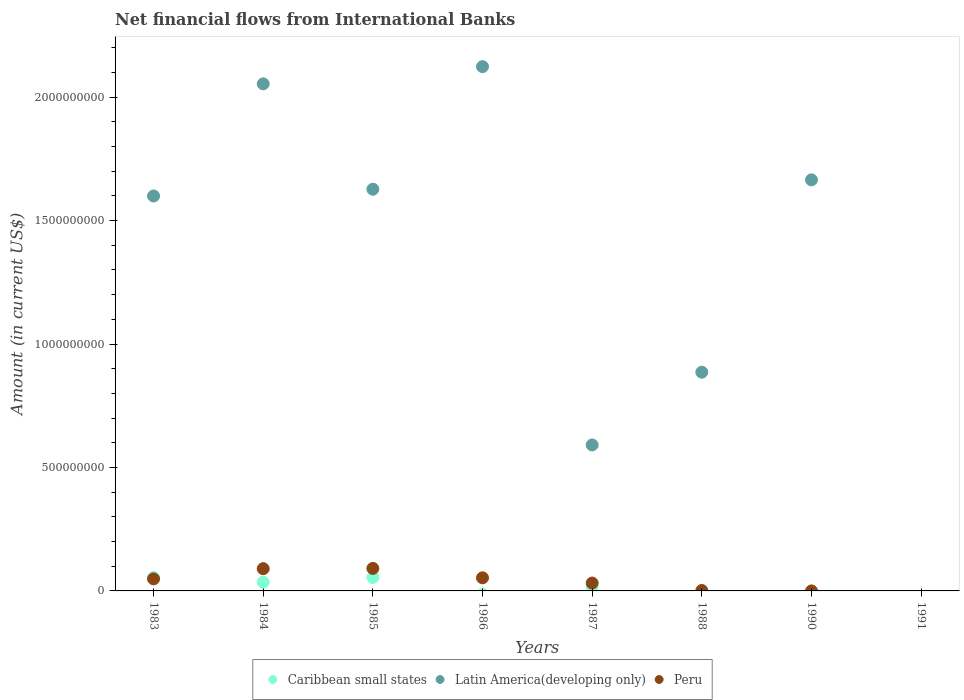Is the number of dotlines equal to the number of legend labels?
Provide a succinct answer. No. What is the net financial aid flows in Peru in 1986?
Make the answer very short. 5.31e+07. Across all years, what is the maximum net financial aid flows in Latin America(developing only)?
Ensure brevity in your answer.  2.12e+09. In which year was the net financial aid flows in Latin America(developing only) maximum?
Keep it short and to the point. 1986. What is the total net financial aid flows in Peru in the graph?
Offer a very short reply. 3.17e+08. What is the difference between the net financial aid flows in Latin America(developing only) in 1985 and that in 1988?
Give a very brief answer. 7.41e+08. What is the difference between the net financial aid flows in Caribbean small states in 1985 and the net financial aid flows in Latin America(developing only) in 1990?
Make the answer very short. -1.61e+09. What is the average net financial aid flows in Caribbean small states per year?
Provide a succinct answer. 2.01e+07. In the year 1987, what is the difference between the net financial aid flows in Peru and net financial aid flows in Latin America(developing only)?
Keep it short and to the point. -5.59e+08. What is the ratio of the net financial aid flows in Peru in 1983 to that in 1985?
Provide a short and direct response. 0.54. Is the net financial aid flows in Caribbean small states in 1983 less than that in 1985?
Give a very brief answer. No. What is the difference between the highest and the second highest net financial aid flows in Caribbean small states?
Provide a short and direct response. 3.59e+04. What is the difference between the highest and the lowest net financial aid flows in Caribbean small states?
Offer a terse response. 5.47e+07. Is the net financial aid flows in Latin America(developing only) strictly less than the net financial aid flows in Peru over the years?
Your answer should be very brief. No. How many dotlines are there?
Provide a succinct answer. 3. Does the graph contain any zero values?
Keep it short and to the point. Yes. Does the graph contain grids?
Offer a very short reply. No. How many legend labels are there?
Your response must be concise. 3. What is the title of the graph?
Make the answer very short. Net financial flows from International Banks. Does "United States" appear as one of the legend labels in the graph?
Your answer should be very brief. No. What is the Amount (in current US$) in Caribbean small states in 1983?
Your answer should be compact. 5.47e+07. What is the Amount (in current US$) of Latin America(developing only) in 1983?
Make the answer very short. 1.60e+09. What is the Amount (in current US$) in Peru in 1983?
Give a very brief answer. 4.88e+07. What is the Amount (in current US$) of Caribbean small states in 1984?
Keep it short and to the point. 3.54e+07. What is the Amount (in current US$) of Latin America(developing only) in 1984?
Your answer should be very brief. 2.05e+09. What is the Amount (in current US$) of Peru in 1984?
Offer a terse response. 9.01e+07. What is the Amount (in current US$) of Caribbean small states in 1985?
Make the answer very short. 5.47e+07. What is the Amount (in current US$) in Latin America(developing only) in 1985?
Offer a terse response. 1.63e+09. What is the Amount (in current US$) in Peru in 1985?
Ensure brevity in your answer.  9.12e+07. What is the Amount (in current US$) in Caribbean small states in 1986?
Ensure brevity in your answer.  0. What is the Amount (in current US$) of Latin America(developing only) in 1986?
Offer a terse response. 2.12e+09. What is the Amount (in current US$) of Peru in 1986?
Make the answer very short. 5.31e+07. What is the Amount (in current US$) in Caribbean small states in 1987?
Offer a very short reply. 1.57e+07. What is the Amount (in current US$) in Latin America(developing only) in 1987?
Your answer should be very brief. 5.91e+08. What is the Amount (in current US$) in Peru in 1987?
Ensure brevity in your answer.  3.19e+07. What is the Amount (in current US$) in Latin America(developing only) in 1988?
Your answer should be very brief. 8.86e+08. What is the Amount (in current US$) of Peru in 1988?
Make the answer very short. 1.75e+06. What is the Amount (in current US$) in Latin America(developing only) in 1990?
Provide a succinct answer. 1.67e+09. What is the Amount (in current US$) of Peru in 1990?
Offer a very short reply. 0. Across all years, what is the maximum Amount (in current US$) in Caribbean small states?
Your answer should be compact. 5.47e+07. Across all years, what is the maximum Amount (in current US$) in Latin America(developing only)?
Your answer should be very brief. 2.12e+09. Across all years, what is the maximum Amount (in current US$) of Peru?
Your response must be concise. 9.12e+07. Across all years, what is the minimum Amount (in current US$) in Caribbean small states?
Your answer should be very brief. 0. Across all years, what is the minimum Amount (in current US$) in Latin America(developing only)?
Provide a short and direct response. 0. What is the total Amount (in current US$) of Caribbean small states in the graph?
Give a very brief answer. 1.60e+08. What is the total Amount (in current US$) of Latin America(developing only) in the graph?
Offer a very short reply. 1.05e+1. What is the total Amount (in current US$) in Peru in the graph?
Your answer should be compact. 3.17e+08. What is the difference between the Amount (in current US$) of Caribbean small states in 1983 and that in 1984?
Keep it short and to the point. 1.93e+07. What is the difference between the Amount (in current US$) of Latin America(developing only) in 1983 and that in 1984?
Your answer should be compact. -4.54e+08. What is the difference between the Amount (in current US$) of Peru in 1983 and that in 1984?
Make the answer very short. -4.13e+07. What is the difference between the Amount (in current US$) in Caribbean small states in 1983 and that in 1985?
Ensure brevity in your answer.  3.59e+04. What is the difference between the Amount (in current US$) in Latin America(developing only) in 1983 and that in 1985?
Make the answer very short. -2.74e+07. What is the difference between the Amount (in current US$) in Peru in 1983 and that in 1985?
Provide a succinct answer. -4.24e+07. What is the difference between the Amount (in current US$) in Latin America(developing only) in 1983 and that in 1986?
Make the answer very short. -5.24e+08. What is the difference between the Amount (in current US$) in Peru in 1983 and that in 1986?
Keep it short and to the point. -4.27e+06. What is the difference between the Amount (in current US$) in Caribbean small states in 1983 and that in 1987?
Offer a very short reply. 3.90e+07. What is the difference between the Amount (in current US$) in Latin America(developing only) in 1983 and that in 1987?
Your answer should be compact. 1.01e+09. What is the difference between the Amount (in current US$) in Peru in 1983 and that in 1987?
Provide a succinct answer. 1.69e+07. What is the difference between the Amount (in current US$) of Latin America(developing only) in 1983 and that in 1988?
Keep it short and to the point. 7.14e+08. What is the difference between the Amount (in current US$) in Peru in 1983 and that in 1988?
Your answer should be compact. 4.70e+07. What is the difference between the Amount (in current US$) in Latin America(developing only) in 1983 and that in 1990?
Your answer should be compact. -6.53e+07. What is the difference between the Amount (in current US$) of Caribbean small states in 1984 and that in 1985?
Give a very brief answer. -1.93e+07. What is the difference between the Amount (in current US$) in Latin America(developing only) in 1984 and that in 1985?
Offer a very short reply. 4.27e+08. What is the difference between the Amount (in current US$) in Peru in 1984 and that in 1985?
Give a very brief answer. -1.07e+06. What is the difference between the Amount (in current US$) in Latin America(developing only) in 1984 and that in 1986?
Your response must be concise. -6.97e+07. What is the difference between the Amount (in current US$) of Peru in 1984 and that in 1986?
Provide a short and direct response. 3.70e+07. What is the difference between the Amount (in current US$) of Caribbean small states in 1984 and that in 1987?
Keep it short and to the point. 1.97e+07. What is the difference between the Amount (in current US$) in Latin America(developing only) in 1984 and that in 1987?
Make the answer very short. 1.46e+09. What is the difference between the Amount (in current US$) in Peru in 1984 and that in 1987?
Offer a very short reply. 5.82e+07. What is the difference between the Amount (in current US$) of Latin America(developing only) in 1984 and that in 1988?
Provide a short and direct response. 1.17e+09. What is the difference between the Amount (in current US$) of Peru in 1984 and that in 1988?
Provide a short and direct response. 8.84e+07. What is the difference between the Amount (in current US$) of Latin America(developing only) in 1984 and that in 1990?
Keep it short and to the point. 3.89e+08. What is the difference between the Amount (in current US$) of Latin America(developing only) in 1985 and that in 1986?
Make the answer very short. -4.96e+08. What is the difference between the Amount (in current US$) of Peru in 1985 and that in 1986?
Give a very brief answer. 3.81e+07. What is the difference between the Amount (in current US$) of Caribbean small states in 1985 and that in 1987?
Offer a very short reply. 3.89e+07. What is the difference between the Amount (in current US$) of Latin America(developing only) in 1985 and that in 1987?
Provide a succinct answer. 1.04e+09. What is the difference between the Amount (in current US$) of Peru in 1985 and that in 1987?
Your response must be concise. 5.93e+07. What is the difference between the Amount (in current US$) in Latin America(developing only) in 1985 and that in 1988?
Offer a terse response. 7.41e+08. What is the difference between the Amount (in current US$) in Peru in 1985 and that in 1988?
Offer a very short reply. 8.94e+07. What is the difference between the Amount (in current US$) of Latin America(developing only) in 1985 and that in 1990?
Make the answer very short. -3.80e+07. What is the difference between the Amount (in current US$) of Latin America(developing only) in 1986 and that in 1987?
Your answer should be very brief. 1.53e+09. What is the difference between the Amount (in current US$) of Peru in 1986 and that in 1987?
Offer a terse response. 2.12e+07. What is the difference between the Amount (in current US$) in Latin America(developing only) in 1986 and that in 1988?
Your answer should be very brief. 1.24e+09. What is the difference between the Amount (in current US$) of Peru in 1986 and that in 1988?
Offer a very short reply. 5.13e+07. What is the difference between the Amount (in current US$) in Latin America(developing only) in 1986 and that in 1990?
Offer a very short reply. 4.59e+08. What is the difference between the Amount (in current US$) of Latin America(developing only) in 1987 and that in 1988?
Provide a short and direct response. -2.95e+08. What is the difference between the Amount (in current US$) in Peru in 1987 and that in 1988?
Give a very brief answer. 3.01e+07. What is the difference between the Amount (in current US$) in Latin America(developing only) in 1987 and that in 1990?
Your response must be concise. -1.07e+09. What is the difference between the Amount (in current US$) in Latin America(developing only) in 1988 and that in 1990?
Your answer should be compact. -7.79e+08. What is the difference between the Amount (in current US$) in Caribbean small states in 1983 and the Amount (in current US$) in Latin America(developing only) in 1984?
Make the answer very short. -2.00e+09. What is the difference between the Amount (in current US$) in Caribbean small states in 1983 and the Amount (in current US$) in Peru in 1984?
Provide a succinct answer. -3.54e+07. What is the difference between the Amount (in current US$) in Latin America(developing only) in 1983 and the Amount (in current US$) in Peru in 1984?
Your answer should be very brief. 1.51e+09. What is the difference between the Amount (in current US$) in Caribbean small states in 1983 and the Amount (in current US$) in Latin America(developing only) in 1985?
Provide a succinct answer. -1.57e+09. What is the difference between the Amount (in current US$) of Caribbean small states in 1983 and the Amount (in current US$) of Peru in 1985?
Keep it short and to the point. -3.65e+07. What is the difference between the Amount (in current US$) of Latin America(developing only) in 1983 and the Amount (in current US$) of Peru in 1985?
Give a very brief answer. 1.51e+09. What is the difference between the Amount (in current US$) of Caribbean small states in 1983 and the Amount (in current US$) of Latin America(developing only) in 1986?
Keep it short and to the point. -2.07e+09. What is the difference between the Amount (in current US$) in Caribbean small states in 1983 and the Amount (in current US$) in Peru in 1986?
Give a very brief answer. 1.63e+06. What is the difference between the Amount (in current US$) of Latin America(developing only) in 1983 and the Amount (in current US$) of Peru in 1986?
Keep it short and to the point. 1.55e+09. What is the difference between the Amount (in current US$) of Caribbean small states in 1983 and the Amount (in current US$) of Latin America(developing only) in 1987?
Provide a short and direct response. -5.37e+08. What is the difference between the Amount (in current US$) in Caribbean small states in 1983 and the Amount (in current US$) in Peru in 1987?
Your response must be concise. 2.28e+07. What is the difference between the Amount (in current US$) of Latin America(developing only) in 1983 and the Amount (in current US$) of Peru in 1987?
Keep it short and to the point. 1.57e+09. What is the difference between the Amount (in current US$) in Caribbean small states in 1983 and the Amount (in current US$) in Latin America(developing only) in 1988?
Keep it short and to the point. -8.31e+08. What is the difference between the Amount (in current US$) of Caribbean small states in 1983 and the Amount (in current US$) of Peru in 1988?
Offer a terse response. 5.29e+07. What is the difference between the Amount (in current US$) of Latin America(developing only) in 1983 and the Amount (in current US$) of Peru in 1988?
Your answer should be compact. 1.60e+09. What is the difference between the Amount (in current US$) in Caribbean small states in 1983 and the Amount (in current US$) in Latin America(developing only) in 1990?
Your answer should be compact. -1.61e+09. What is the difference between the Amount (in current US$) of Caribbean small states in 1984 and the Amount (in current US$) of Latin America(developing only) in 1985?
Provide a short and direct response. -1.59e+09. What is the difference between the Amount (in current US$) of Caribbean small states in 1984 and the Amount (in current US$) of Peru in 1985?
Give a very brief answer. -5.58e+07. What is the difference between the Amount (in current US$) of Latin America(developing only) in 1984 and the Amount (in current US$) of Peru in 1985?
Give a very brief answer. 1.96e+09. What is the difference between the Amount (in current US$) of Caribbean small states in 1984 and the Amount (in current US$) of Latin America(developing only) in 1986?
Your answer should be compact. -2.09e+09. What is the difference between the Amount (in current US$) of Caribbean small states in 1984 and the Amount (in current US$) of Peru in 1986?
Provide a succinct answer. -1.77e+07. What is the difference between the Amount (in current US$) in Latin America(developing only) in 1984 and the Amount (in current US$) in Peru in 1986?
Your answer should be very brief. 2.00e+09. What is the difference between the Amount (in current US$) of Caribbean small states in 1984 and the Amount (in current US$) of Latin America(developing only) in 1987?
Give a very brief answer. -5.56e+08. What is the difference between the Amount (in current US$) of Caribbean small states in 1984 and the Amount (in current US$) of Peru in 1987?
Provide a succinct answer. 3.53e+06. What is the difference between the Amount (in current US$) in Latin America(developing only) in 1984 and the Amount (in current US$) in Peru in 1987?
Ensure brevity in your answer.  2.02e+09. What is the difference between the Amount (in current US$) in Caribbean small states in 1984 and the Amount (in current US$) in Latin America(developing only) in 1988?
Provide a short and direct response. -8.51e+08. What is the difference between the Amount (in current US$) of Caribbean small states in 1984 and the Amount (in current US$) of Peru in 1988?
Your answer should be compact. 3.36e+07. What is the difference between the Amount (in current US$) of Latin America(developing only) in 1984 and the Amount (in current US$) of Peru in 1988?
Give a very brief answer. 2.05e+09. What is the difference between the Amount (in current US$) in Caribbean small states in 1984 and the Amount (in current US$) in Latin America(developing only) in 1990?
Offer a very short reply. -1.63e+09. What is the difference between the Amount (in current US$) of Caribbean small states in 1985 and the Amount (in current US$) of Latin America(developing only) in 1986?
Provide a succinct answer. -2.07e+09. What is the difference between the Amount (in current US$) of Caribbean small states in 1985 and the Amount (in current US$) of Peru in 1986?
Your answer should be compact. 1.60e+06. What is the difference between the Amount (in current US$) of Latin America(developing only) in 1985 and the Amount (in current US$) of Peru in 1986?
Your answer should be compact. 1.57e+09. What is the difference between the Amount (in current US$) of Caribbean small states in 1985 and the Amount (in current US$) of Latin America(developing only) in 1987?
Your answer should be very brief. -5.37e+08. What is the difference between the Amount (in current US$) of Caribbean small states in 1985 and the Amount (in current US$) of Peru in 1987?
Offer a very short reply. 2.28e+07. What is the difference between the Amount (in current US$) of Latin America(developing only) in 1985 and the Amount (in current US$) of Peru in 1987?
Provide a succinct answer. 1.60e+09. What is the difference between the Amount (in current US$) in Caribbean small states in 1985 and the Amount (in current US$) in Latin America(developing only) in 1988?
Ensure brevity in your answer.  -8.31e+08. What is the difference between the Amount (in current US$) of Caribbean small states in 1985 and the Amount (in current US$) of Peru in 1988?
Keep it short and to the point. 5.29e+07. What is the difference between the Amount (in current US$) of Latin America(developing only) in 1985 and the Amount (in current US$) of Peru in 1988?
Your answer should be compact. 1.63e+09. What is the difference between the Amount (in current US$) of Caribbean small states in 1985 and the Amount (in current US$) of Latin America(developing only) in 1990?
Ensure brevity in your answer.  -1.61e+09. What is the difference between the Amount (in current US$) in Latin America(developing only) in 1986 and the Amount (in current US$) in Peru in 1987?
Provide a succinct answer. 2.09e+09. What is the difference between the Amount (in current US$) in Latin America(developing only) in 1986 and the Amount (in current US$) in Peru in 1988?
Ensure brevity in your answer.  2.12e+09. What is the difference between the Amount (in current US$) in Caribbean small states in 1987 and the Amount (in current US$) in Latin America(developing only) in 1988?
Your response must be concise. -8.70e+08. What is the difference between the Amount (in current US$) of Caribbean small states in 1987 and the Amount (in current US$) of Peru in 1988?
Provide a succinct answer. 1.40e+07. What is the difference between the Amount (in current US$) of Latin America(developing only) in 1987 and the Amount (in current US$) of Peru in 1988?
Your answer should be compact. 5.90e+08. What is the difference between the Amount (in current US$) in Caribbean small states in 1987 and the Amount (in current US$) in Latin America(developing only) in 1990?
Your response must be concise. -1.65e+09. What is the average Amount (in current US$) in Caribbean small states per year?
Give a very brief answer. 2.01e+07. What is the average Amount (in current US$) of Latin America(developing only) per year?
Provide a succinct answer. 1.32e+09. What is the average Amount (in current US$) of Peru per year?
Your answer should be very brief. 3.96e+07. In the year 1983, what is the difference between the Amount (in current US$) of Caribbean small states and Amount (in current US$) of Latin America(developing only)?
Your answer should be compact. -1.55e+09. In the year 1983, what is the difference between the Amount (in current US$) of Caribbean small states and Amount (in current US$) of Peru?
Offer a terse response. 5.90e+06. In the year 1983, what is the difference between the Amount (in current US$) in Latin America(developing only) and Amount (in current US$) in Peru?
Give a very brief answer. 1.55e+09. In the year 1984, what is the difference between the Amount (in current US$) of Caribbean small states and Amount (in current US$) of Latin America(developing only)?
Give a very brief answer. -2.02e+09. In the year 1984, what is the difference between the Amount (in current US$) in Caribbean small states and Amount (in current US$) in Peru?
Ensure brevity in your answer.  -5.47e+07. In the year 1984, what is the difference between the Amount (in current US$) of Latin America(developing only) and Amount (in current US$) of Peru?
Offer a very short reply. 1.96e+09. In the year 1985, what is the difference between the Amount (in current US$) of Caribbean small states and Amount (in current US$) of Latin America(developing only)?
Ensure brevity in your answer.  -1.57e+09. In the year 1985, what is the difference between the Amount (in current US$) of Caribbean small states and Amount (in current US$) of Peru?
Provide a succinct answer. -3.65e+07. In the year 1985, what is the difference between the Amount (in current US$) in Latin America(developing only) and Amount (in current US$) in Peru?
Ensure brevity in your answer.  1.54e+09. In the year 1986, what is the difference between the Amount (in current US$) of Latin America(developing only) and Amount (in current US$) of Peru?
Provide a short and direct response. 2.07e+09. In the year 1987, what is the difference between the Amount (in current US$) in Caribbean small states and Amount (in current US$) in Latin America(developing only)?
Offer a terse response. -5.76e+08. In the year 1987, what is the difference between the Amount (in current US$) of Caribbean small states and Amount (in current US$) of Peru?
Ensure brevity in your answer.  -1.61e+07. In the year 1987, what is the difference between the Amount (in current US$) in Latin America(developing only) and Amount (in current US$) in Peru?
Make the answer very short. 5.59e+08. In the year 1988, what is the difference between the Amount (in current US$) in Latin America(developing only) and Amount (in current US$) in Peru?
Make the answer very short. 8.84e+08. What is the ratio of the Amount (in current US$) in Caribbean small states in 1983 to that in 1984?
Provide a succinct answer. 1.55. What is the ratio of the Amount (in current US$) in Latin America(developing only) in 1983 to that in 1984?
Offer a terse response. 0.78. What is the ratio of the Amount (in current US$) in Peru in 1983 to that in 1984?
Offer a very short reply. 0.54. What is the ratio of the Amount (in current US$) in Latin America(developing only) in 1983 to that in 1985?
Offer a very short reply. 0.98. What is the ratio of the Amount (in current US$) in Peru in 1983 to that in 1985?
Provide a succinct answer. 0.54. What is the ratio of the Amount (in current US$) of Latin America(developing only) in 1983 to that in 1986?
Keep it short and to the point. 0.75. What is the ratio of the Amount (in current US$) in Peru in 1983 to that in 1986?
Offer a terse response. 0.92. What is the ratio of the Amount (in current US$) of Caribbean small states in 1983 to that in 1987?
Provide a succinct answer. 3.48. What is the ratio of the Amount (in current US$) of Latin America(developing only) in 1983 to that in 1987?
Your answer should be compact. 2.71. What is the ratio of the Amount (in current US$) of Peru in 1983 to that in 1987?
Give a very brief answer. 1.53. What is the ratio of the Amount (in current US$) in Latin America(developing only) in 1983 to that in 1988?
Ensure brevity in your answer.  1.81. What is the ratio of the Amount (in current US$) in Peru in 1983 to that in 1988?
Your answer should be compact. 27.84. What is the ratio of the Amount (in current US$) of Latin America(developing only) in 1983 to that in 1990?
Make the answer very short. 0.96. What is the ratio of the Amount (in current US$) in Caribbean small states in 1984 to that in 1985?
Give a very brief answer. 0.65. What is the ratio of the Amount (in current US$) in Latin America(developing only) in 1984 to that in 1985?
Keep it short and to the point. 1.26. What is the ratio of the Amount (in current US$) in Latin America(developing only) in 1984 to that in 1986?
Provide a succinct answer. 0.97. What is the ratio of the Amount (in current US$) in Peru in 1984 to that in 1986?
Provide a short and direct response. 1.7. What is the ratio of the Amount (in current US$) of Caribbean small states in 1984 to that in 1987?
Keep it short and to the point. 2.25. What is the ratio of the Amount (in current US$) in Latin America(developing only) in 1984 to that in 1987?
Keep it short and to the point. 3.47. What is the ratio of the Amount (in current US$) of Peru in 1984 to that in 1987?
Provide a succinct answer. 2.83. What is the ratio of the Amount (in current US$) of Latin America(developing only) in 1984 to that in 1988?
Provide a short and direct response. 2.32. What is the ratio of the Amount (in current US$) of Peru in 1984 to that in 1988?
Your response must be concise. 51.4. What is the ratio of the Amount (in current US$) of Latin America(developing only) in 1984 to that in 1990?
Provide a succinct answer. 1.23. What is the ratio of the Amount (in current US$) in Latin America(developing only) in 1985 to that in 1986?
Keep it short and to the point. 0.77. What is the ratio of the Amount (in current US$) of Peru in 1985 to that in 1986?
Make the answer very short. 1.72. What is the ratio of the Amount (in current US$) in Caribbean small states in 1985 to that in 1987?
Your answer should be very brief. 3.48. What is the ratio of the Amount (in current US$) of Latin America(developing only) in 1985 to that in 1987?
Your response must be concise. 2.75. What is the ratio of the Amount (in current US$) in Peru in 1985 to that in 1987?
Provide a succinct answer. 2.86. What is the ratio of the Amount (in current US$) in Latin America(developing only) in 1985 to that in 1988?
Your response must be concise. 1.84. What is the ratio of the Amount (in current US$) of Peru in 1985 to that in 1988?
Your response must be concise. 52.01. What is the ratio of the Amount (in current US$) of Latin America(developing only) in 1985 to that in 1990?
Keep it short and to the point. 0.98. What is the ratio of the Amount (in current US$) of Latin America(developing only) in 1986 to that in 1987?
Your answer should be very brief. 3.59. What is the ratio of the Amount (in current US$) in Peru in 1986 to that in 1987?
Your response must be concise. 1.67. What is the ratio of the Amount (in current US$) of Latin America(developing only) in 1986 to that in 1988?
Your answer should be compact. 2.4. What is the ratio of the Amount (in current US$) in Peru in 1986 to that in 1988?
Your answer should be very brief. 30.27. What is the ratio of the Amount (in current US$) of Latin America(developing only) in 1986 to that in 1990?
Give a very brief answer. 1.28. What is the ratio of the Amount (in current US$) in Latin America(developing only) in 1987 to that in 1988?
Your response must be concise. 0.67. What is the ratio of the Amount (in current US$) of Peru in 1987 to that in 1988?
Your response must be concise. 18.18. What is the ratio of the Amount (in current US$) of Latin America(developing only) in 1987 to that in 1990?
Offer a terse response. 0.36. What is the ratio of the Amount (in current US$) in Latin America(developing only) in 1988 to that in 1990?
Your answer should be very brief. 0.53. What is the difference between the highest and the second highest Amount (in current US$) of Caribbean small states?
Provide a succinct answer. 3.59e+04. What is the difference between the highest and the second highest Amount (in current US$) of Latin America(developing only)?
Provide a short and direct response. 6.97e+07. What is the difference between the highest and the second highest Amount (in current US$) in Peru?
Provide a succinct answer. 1.07e+06. What is the difference between the highest and the lowest Amount (in current US$) of Caribbean small states?
Give a very brief answer. 5.47e+07. What is the difference between the highest and the lowest Amount (in current US$) of Latin America(developing only)?
Ensure brevity in your answer.  2.12e+09. What is the difference between the highest and the lowest Amount (in current US$) of Peru?
Offer a terse response. 9.12e+07. 